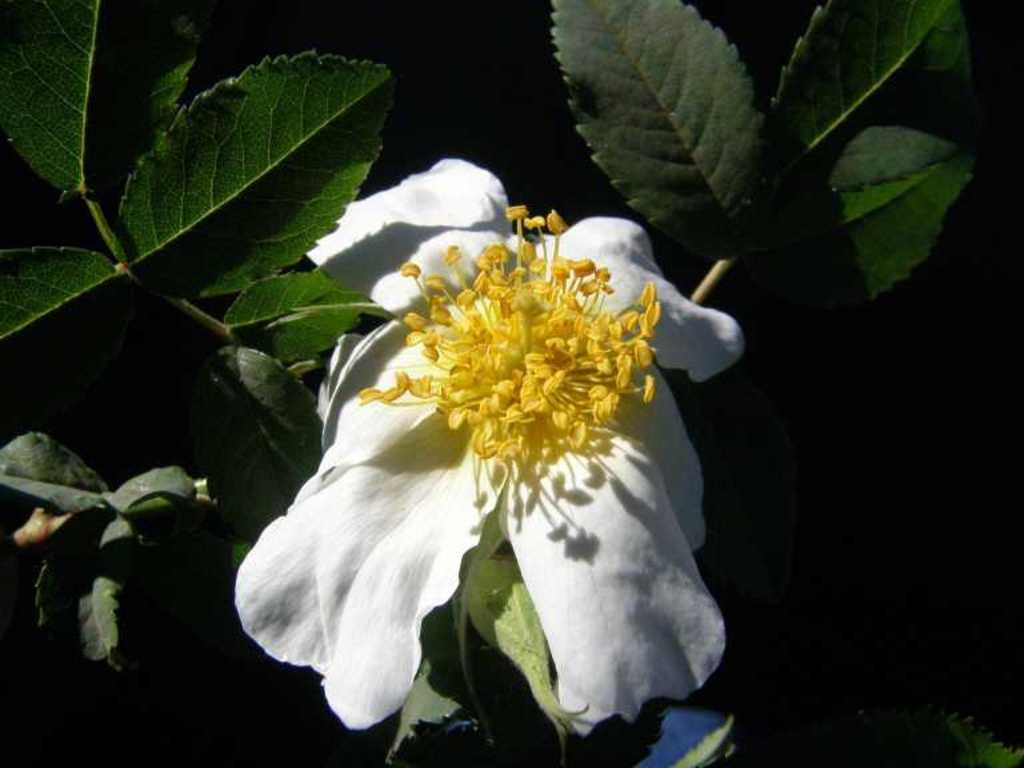What type of flower is present in the image? There is a white and yellow color flower in the image. What color are the leaves in the image? There are dew green color leaves in the image. What color is the background of the image? The background of the image is black. What direction is the flower facing in the image? The direction the flower is facing cannot be determined from the image, as it is a two-dimensional representation. 